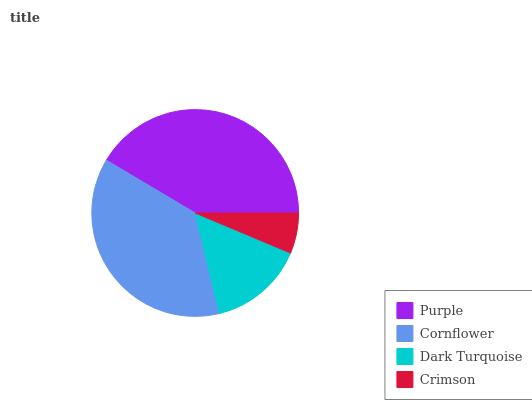Is Crimson the minimum?
Answer yes or no. Yes. Is Purple the maximum?
Answer yes or no. Yes. Is Cornflower the minimum?
Answer yes or no. No. Is Cornflower the maximum?
Answer yes or no. No. Is Purple greater than Cornflower?
Answer yes or no. Yes. Is Cornflower less than Purple?
Answer yes or no. Yes. Is Cornflower greater than Purple?
Answer yes or no. No. Is Purple less than Cornflower?
Answer yes or no. No. Is Cornflower the high median?
Answer yes or no. Yes. Is Dark Turquoise the low median?
Answer yes or no. Yes. Is Purple the high median?
Answer yes or no. No. Is Cornflower the low median?
Answer yes or no. No. 